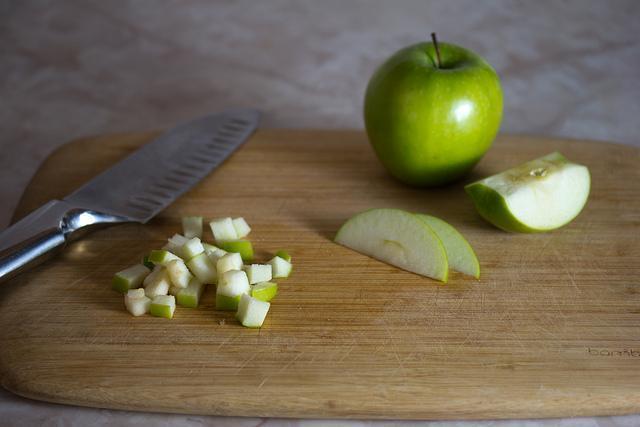How many apples have been cut up?
Give a very brief answer. 1. How many knives can be seen?
Give a very brief answer. 1. How many apples are visible?
Give a very brief answer. 2. 